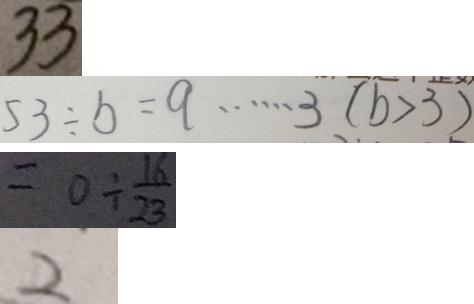<formula> <loc_0><loc_0><loc_500><loc_500>3 3 
 5 3 \div b = q \cdots 3 ( b > 3 ) 
 = 0 \div \frac { 1 6 } { 2 3 } 
 2</formula> 